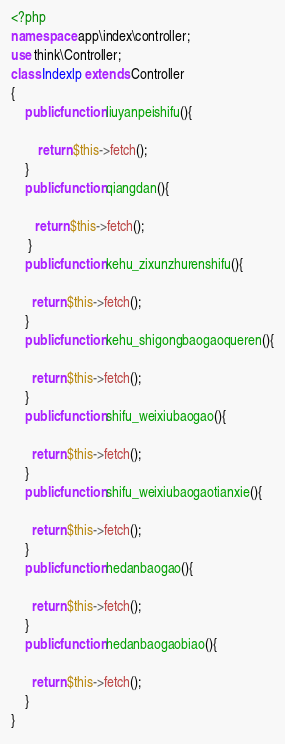<code> <loc_0><loc_0><loc_500><loc_500><_PHP_><?php
namespace app\index\controller;
use think\Controller;
class Indexlp extends Controller
{
    public function liuyanpeishifu(){
        
        return $this->fetch();
    }
    public function qiangdan(){
                
       return $this->fetch();
     }
    public function kehu_zixunzhurenshifu(){
        
      return $this->fetch();
    }
    public function kehu_shigongbaogaoqueren(){
        
      return $this->fetch();
    }
    public function shifu_weixiubaogao(){
        
      return $this->fetch();
    }
    public function shifu_weixiubaogaotianxie(){
        
      return $this->fetch();
    }
    public function hedanbaogao(){
        
      return $this->fetch();
    }
    public function hedanbaogaobiao(){
        
      return $this->fetch();
    }
}</code> 